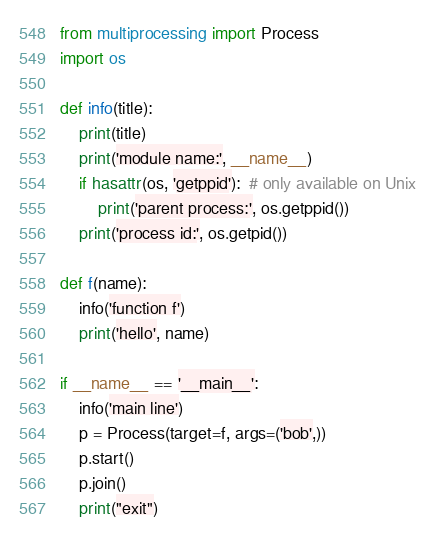Convert code to text. <code><loc_0><loc_0><loc_500><loc_500><_Python_>from multiprocessing import Process
import os

def info(title):
    print(title)
    print('module name:', __name__)
    if hasattr(os, 'getppid'):  # only available on Unix
        print('parent process:', os.getppid())
    print('process id:', os.getpid())

def f(name):
    info('function f')
    print('hello', name)

if __name__ == '__main__':
    info('main line')
    p = Process(target=f, args=('bob',))
    p.start()
    p.join()
    print("exit")</code> 